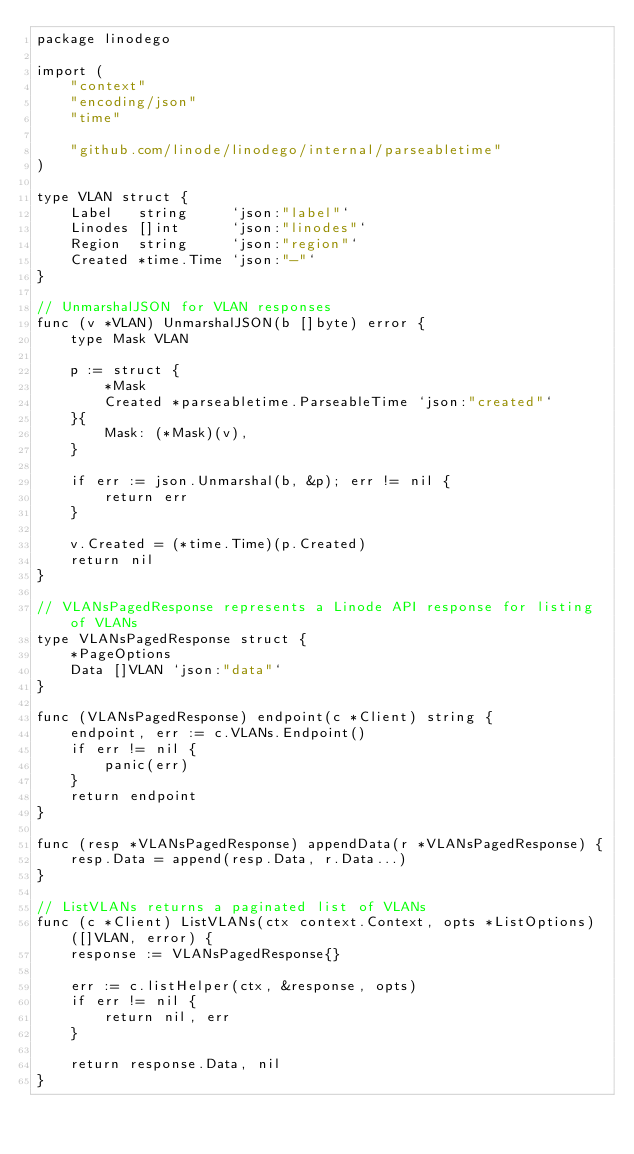Convert code to text. <code><loc_0><loc_0><loc_500><loc_500><_Go_>package linodego

import (
	"context"
	"encoding/json"
	"time"

	"github.com/linode/linodego/internal/parseabletime"
)

type VLAN struct {
	Label   string     `json:"label"`
	Linodes []int      `json:"linodes"`
	Region  string     `json:"region"`
	Created *time.Time `json:"-"`
}

// UnmarshalJSON for VLAN responses
func (v *VLAN) UnmarshalJSON(b []byte) error {
	type Mask VLAN

	p := struct {
		*Mask
		Created *parseabletime.ParseableTime `json:"created"`
	}{
		Mask: (*Mask)(v),
	}

	if err := json.Unmarshal(b, &p); err != nil {
		return err
	}

	v.Created = (*time.Time)(p.Created)
	return nil
}

// VLANsPagedResponse represents a Linode API response for listing of VLANs
type VLANsPagedResponse struct {
	*PageOptions
	Data []VLAN `json:"data"`
}

func (VLANsPagedResponse) endpoint(c *Client) string {
	endpoint, err := c.VLANs.Endpoint()
	if err != nil {
		panic(err)
	}
	return endpoint
}

func (resp *VLANsPagedResponse) appendData(r *VLANsPagedResponse) {
	resp.Data = append(resp.Data, r.Data...)
}

// ListVLANs returns a paginated list of VLANs
func (c *Client) ListVLANs(ctx context.Context, opts *ListOptions) ([]VLAN, error) {
	response := VLANsPagedResponse{}

	err := c.listHelper(ctx, &response, opts)
	if err != nil {
		return nil, err
	}

	return response.Data, nil
}
</code> 